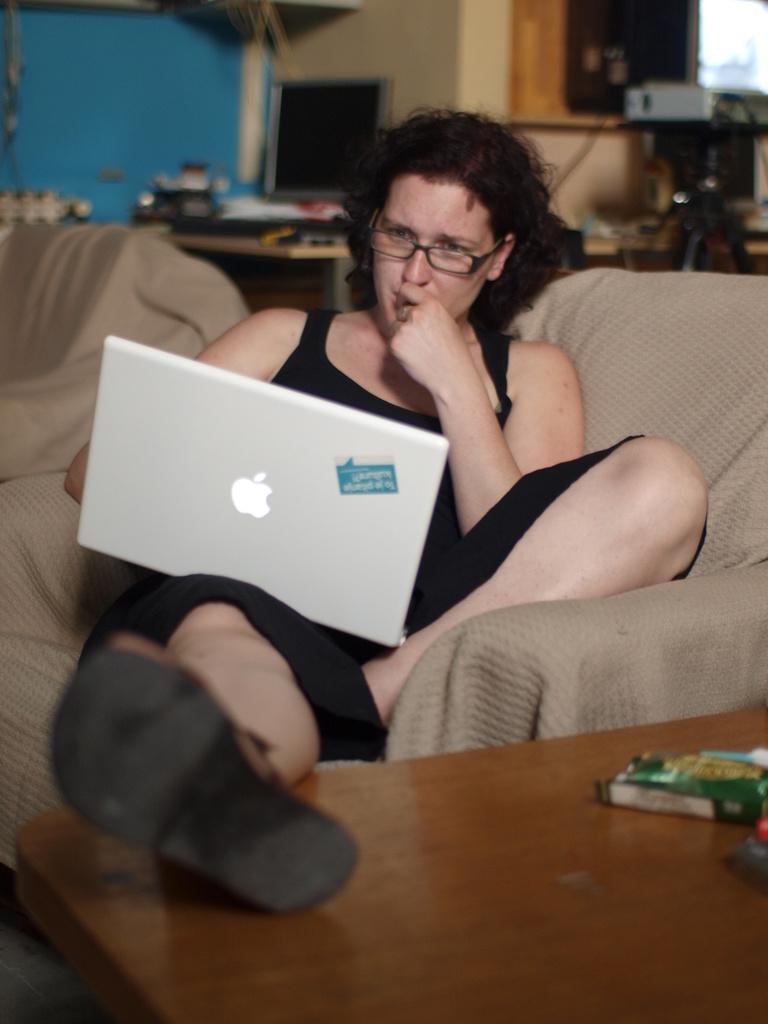Can you describe this image briefly? In the center of the image there is a lady who is holding a laptop is sitting on a sofa. There is a table. In the background there is a computer, a wall, a window and a projector which is placed on a stand. 